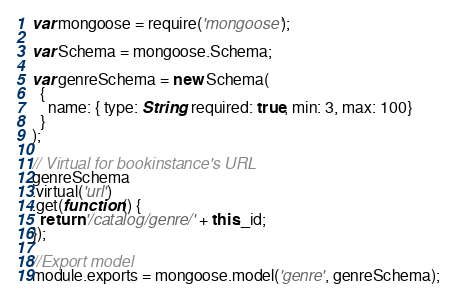Convert code to text. <code><loc_0><loc_0><loc_500><loc_500><_JavaScript_>var mongoose = require('mongoose');

var Schema = mongoose.Schema;

var genreSchema = new Schema(
  {
    name: { type: String, required: true, min: 3, max: 100}
  }
);

// Virtual for bookinstance's URL
genreSchema
.virtual('url')
.get(function () {
  return '/catalog/genre/' + this._id;
});

//Export model
module.exports = mongoose.model('genre', genreSchema);</code> 